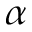<formula> <loc_0><loc_0><loc_500><loc_500>\alpha</formula> 